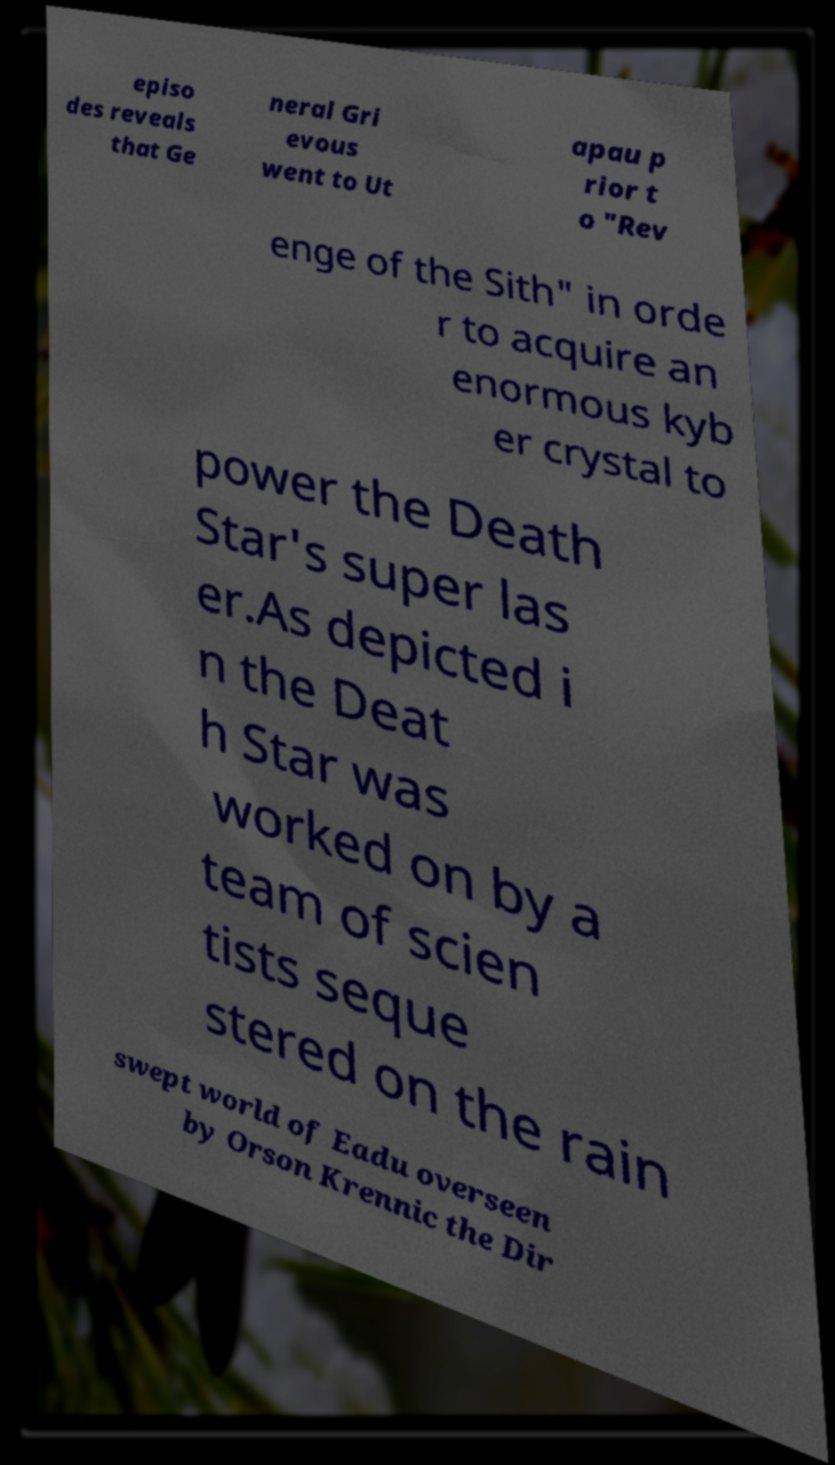Could you assist in decoding the text presented in this image and type it out clearly? episo des reveals that Ge neral Gri evous went to Ut apau p rior t o "Rev enge of the Sith" in orde r to acquire an enormous kyb er crystal to power the Death Star's super las er.As depicted i n the Deat h Star was worked on by a team of scien tists seque stered on the rain swept world of Eadu overseen by Orson Krennic the Dir 